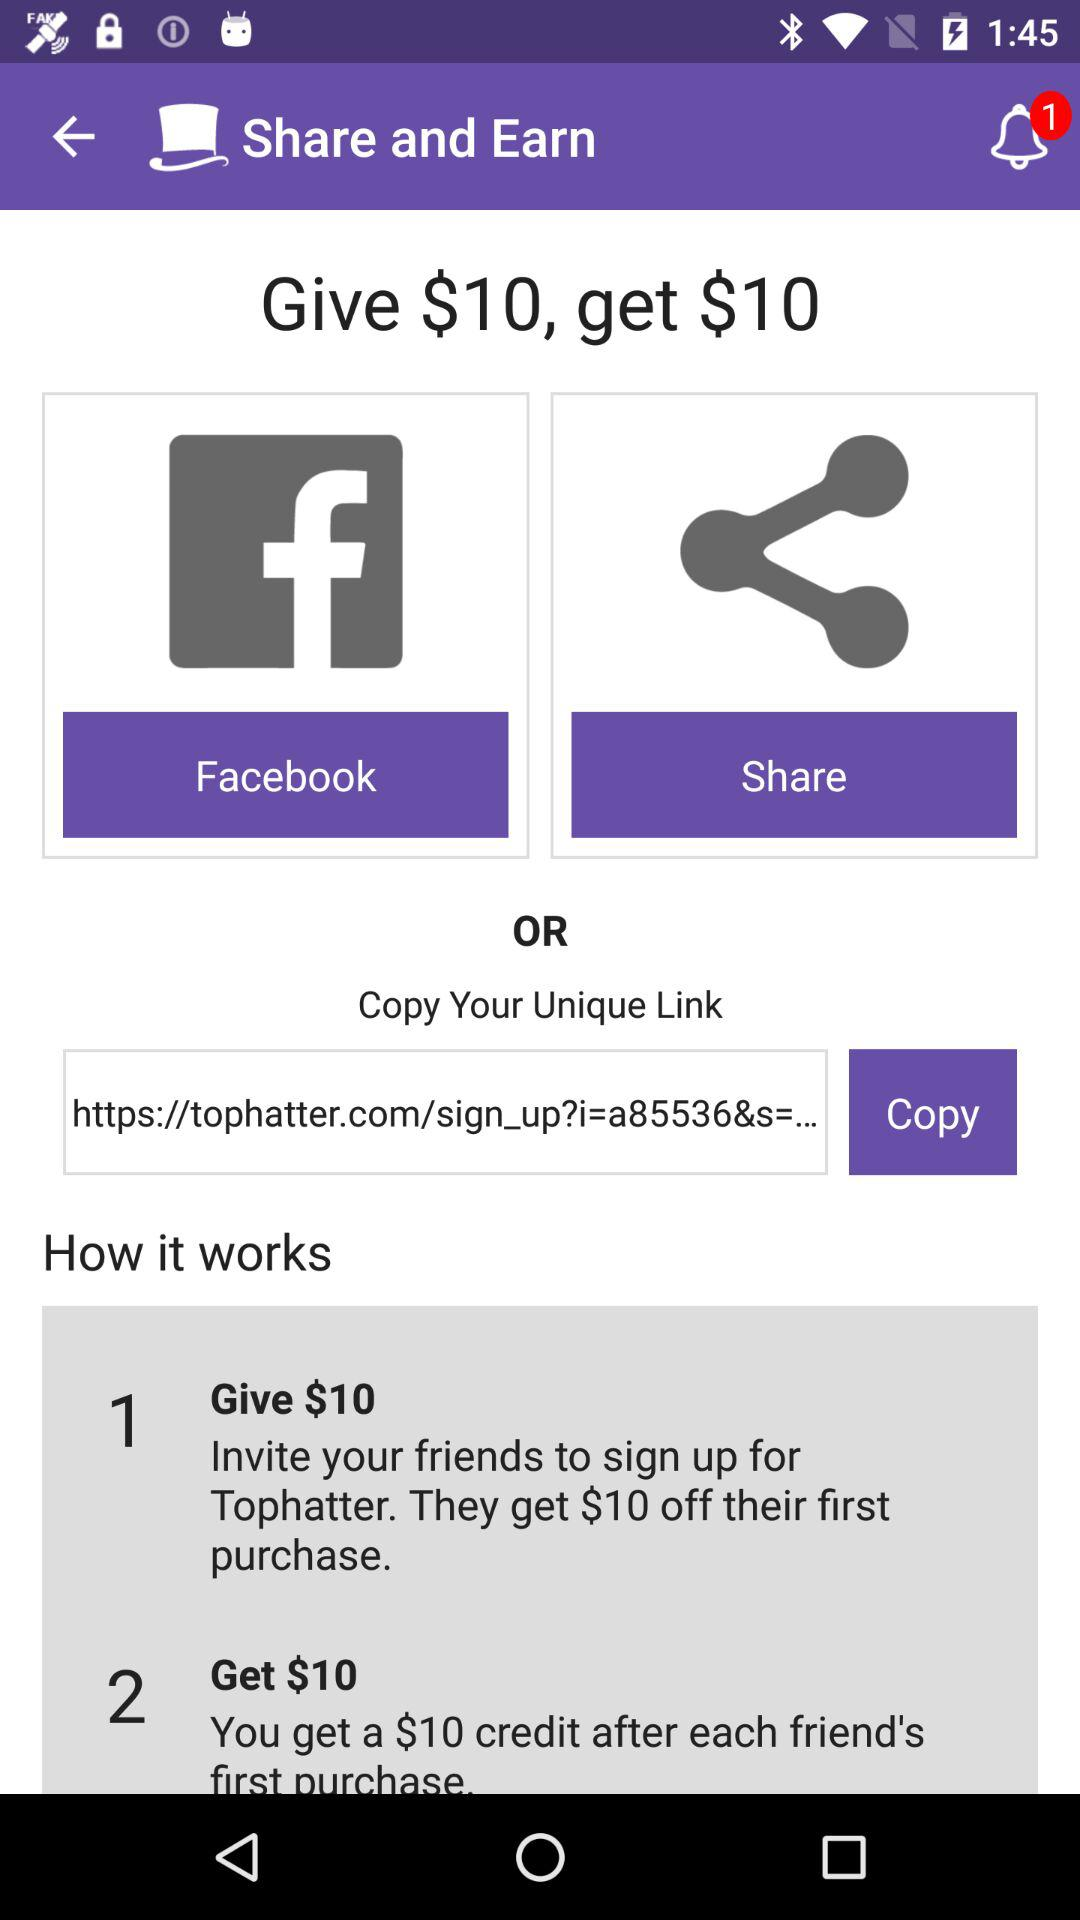How many steps are there in the process of sharing a link with a friend?
Answer the question using a single word or phrase. 3 